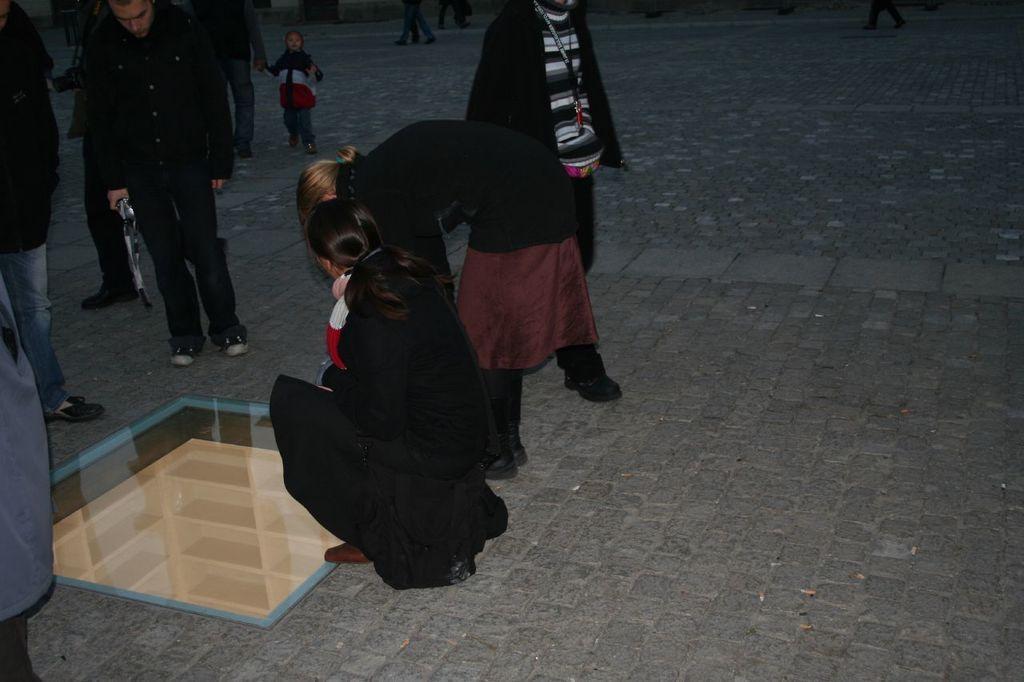In one or two sentences, can you explain what this image depicts? In this picture I can see group of people standing, there is a person in a squat position, this is looking like underground cabin. 